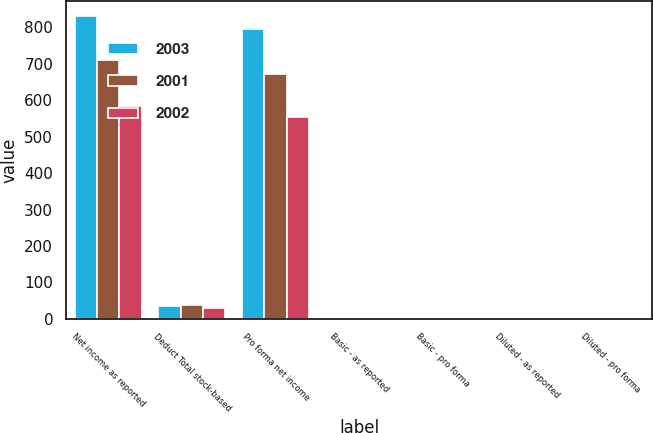Convert chart. <chart><loc_0><loc_0><loc_500><loc_500><stacked_bar_chart><ecel><fcel>Net income as reported<fcel>Deduct Total stock-based<fcel>Pro forma net income<fcel>Basic - as reported<fcel>Basic - pro forma<fcel>Diluted - as reported<fcel>Diluted - pro forma<nl><fcel>2003<fcel>830<fcel>34<fcel>796<fcel>2.79<fcel>2.67<fcel>2.74<fcel>2.63<nl><fcel>2001<fcel>710<fcel>37<fcel>673<fcel>2.38<fcel>2.26<fcel>2.34<fcel>2.22<nl><fcel>2002<fcel>584<fcel>31<fcel>553<fcel>2.02<fcel>1.92<fcel>1.99<fcel>1.89<nl></chart> 